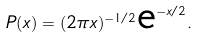<formula> <loc_0><loc_0><loc_500><loc_500>P ( x ) = ( 2 \pi x ) ^ { - 1 / 2 } { \text {e} } ^ { - x / 2 } .</formula> 